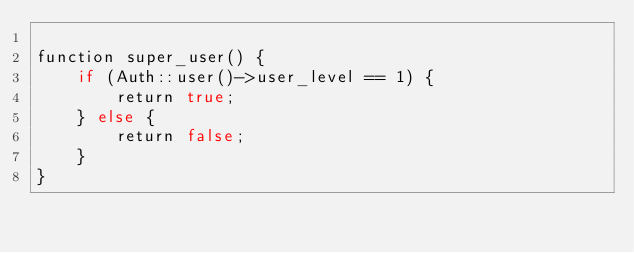Convert code to text. <code><loc_0><loc_0><loc_500><loc_500><_PHP_>
function super_user() {
    if (Auth::user()->user_level == 1) {
        return true;
    } else {
        return false;
    }
}

</code> 